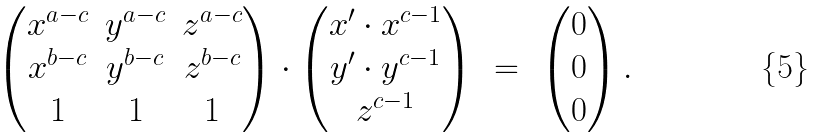<formula> <loc_0><loc_0><loc_500><loc_500>\begin{pmatrix} x ^ { a - c } & y ^ { a - c } & z ^ { a - c } \\ x ^ { b - c } & y ^ { b - c } & z ^ { b - c } \\ 1 & 1 & 1 \end{pmatrix} \cdot \begin{pmatrix} x ^ { \prime } \cdot x ^ { c - 1 } \\ y ^ { \prime } \cdot y ^ { c - 1 } \\ z ^ { c - 1 } \end{pmatrix} \ = \ \begin{pmatrix} 0 \\ 0 \\ 0 \end{pmatrix} .</formula> 